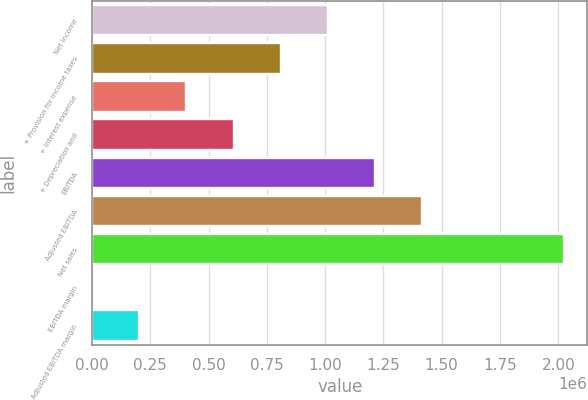Convert chart. <chart><loc_0><loc_0><loc_500><loc_500><bar_chart><fcel>Net income<fcel>+ Provision for income taxes<fcel>+ Interest expense<fcel>+ Depreciation and<fcel>EBITDA<fcel>Adjusted EBITDA<fcel>Net sales<fcel>EBITDA margin<fcel>Adjusted EBITDA margin<nl><fcel>1.01208e+06<fcel>809666<fcel>404845<fcel>607255<fcel>1.21449e+06<fcel>1.4169e+06<fcel>2.02413e+06<fcel>23.5<fcel>202434<nl></chart> 